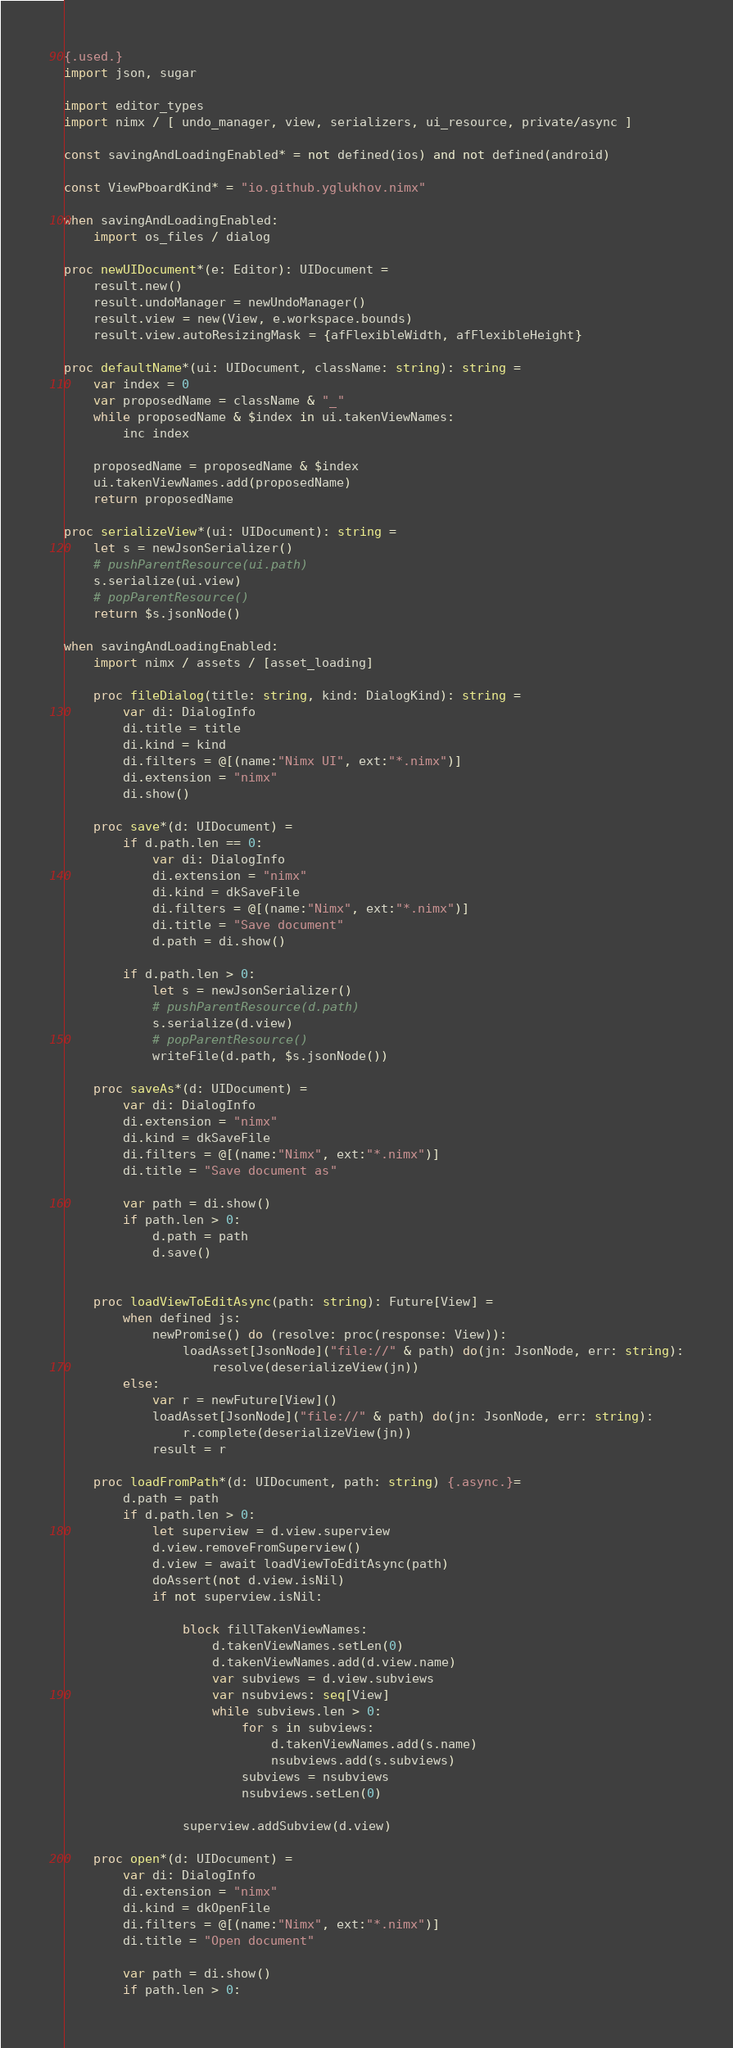<code> <loc_0><loc_0><loc_500><loc_500><_Nim_>{.used.}
import json, sugar

import editor_types
import nimx / [ undo_manager, view, serializers, ui_resource, private/async ]

const savingAndLoadingEnabled* = not defined(ios) and not defined(android)

const ViewPboardKind* = "io.github.yglukhov.nimx"

when savingAndLoadingEnabled:
    import os_files / dialog

proc newUIDocument*(e: Editor): UIDocument =
    result.new()
    result.undoManager = newUndoManager()
    result.view = new(View, e.workspace.bounds)
    result.view.autoResizingMask = {afFlexibleWidth, afFlexibleHeight}

proc defaultName*(ui: UIDocument, className: string): string =
    var index = 0
    var proposedName = className & "_"
    while proposedName & $index in ui.takenViewNames:
        inc index

    proposedName = proposedName & $index
    ui.takenViewNames.add(proposedName)
    return proposedName

proc serializeView*(ui: UIDocument): string =
    let s = newJsonSerializer()
    # pushParentResource(ui.path)
    s.serialize(ui.view)
    # popParentResource()
    return $s.jsonNode()

when savingAndLoadingEnabled:
    import nimx / assets / [asset_loading]

    proc fileDialog(title: string, kind: DialogKind): string =
        var di: DialogInfo
        di.title = title
        di.kind = kind
        di.filters = @[(name:"Nimx UI", ext:"*.nimx")]
        di.extension = "nimx"
        di.show()

    proc save*(d: UIDocument) =
        if d.path.len == 0:
            var di: DialogInfo
            di.extension = "nimx"
            di.kind = dkSaveFile
            di.filters = @[(name:"Nimx", ext:"*.nimx")]
            di.title = "Save document"
            d.path = di.show()

        if d.path.len > 0:
            let s = newJsonSerializer()
            # pushParentResource(d.path)
            s.serialize(d.view)
            # popParentResource()
            writeFile(d.path, $s.jsonNode())

    proc saveAs*(d: UIDocument) =
        var di: DialogInfo
        di.extension = "nimx"
        di.kind = dkSaveFile
        di.filters = @[(name:"Nimx", ext:"*.nimx")]
        di.title = "Save document as"

        var path = di.show()
        if path.len > 0:
            d.path = path
            d.save()


    proc loadViewToEditAsync(path: string): Future[View] =
        when defined js:
            newPromise() do (resolve: proc(response: View)):
                loadAsset[JsonNode]("file://" & path) do(jn: JsonNode, err: string):
                    resolve(deserializeView(jn))
        else:
            var r = newFuture[View]()
            loadAsset[JsonNode]("file://" & path) do(jn: JsonNode, err: string):
                r.complete(deserializeView(jn))
            result = r

    proc loadFromPath*(d: UIDocument, path: string) {.async.}=
        d.path = path
        if d.path.len > 0:
            let superview = d.view.superview
            d.view.removeFromSuperview()
            d.view = await loadViewToEditAsync(path)
            doAssert(not d.view.isNil)
            if not superview.isNil:

                block fillTakenViewNames:
                    d.takenViewNames.setLen(0)
                    d.takenViewNames.add(d.view.name)
                    var subviews = d.view.subviews
                    var nsubviews: seq[View]
                    while subviews.len > 0:
                        for s in subviews:
                            d.takenViewNames.add(s.name)
                            nsubviews.add(s.subviews)
                        subviews = nsubviews
                        nsubviews.setLen(0)

                superview.addSubview(d.view)

    proc open*(d: UIDocument) =
        var di: DialogInfo
        di.extension = "nimx"
        di.kind = dkOpenFile
        di.filters = @[(name:"Nimx", ext:"*.nimx")]
        di.title = "Open document"

        var path = di.show()
        if path.len > 0:</code> 